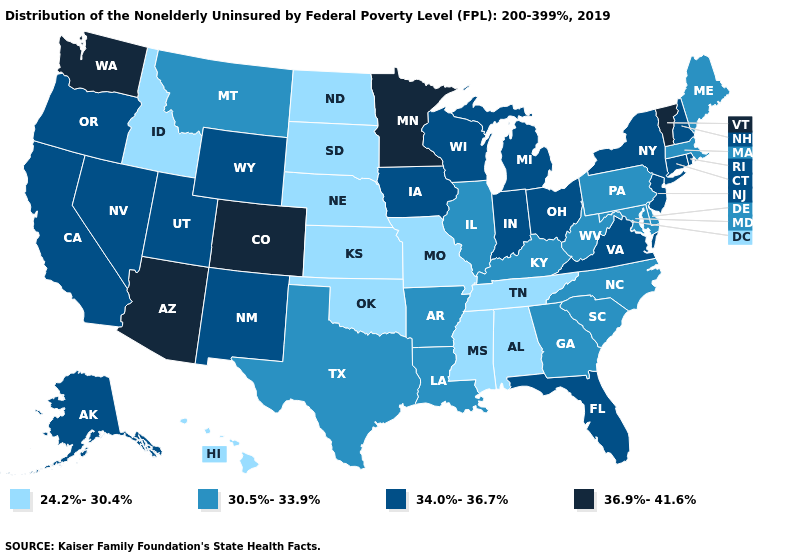Is the legend a continuous bar?
Be succinct. No. Name the states that have a value in the range 24.2%-30.4%?
Be succinct. Alabama, Hawaii, Idaho, Kansas, Mississippi, Missouri, Nebraska, North Dakota, Oklahoma, South Dakota, Tennessee. Among the states that border Connecticut , which have the highest value?
Answer briefly. New York, Rhode Island. Does the map have missing data?
Keep it brief. No. Name the states that have a value in the range 34.0%-36.7%?
Write a very short answer. Alaska, California, Connecticut, Florida, Indiana, Iowa, Michigan, Nevada, New Hampshire, New Jersey, New Mexico, New York, Ohio, Oregon, Rhode Island, Utah, Virginia, Wisconsin, Wyoming. What is the value of Tennessee?
Short answer required. 24.2%-30.4%. Does Delaware have the lowest value in the South?
Concise answer only. No. Does Missouri have the lowest value in the USA?
Give a very brief answer. Yes. Name the states that have a value in the range 34.0%-36.7%?
Write a very short answer. Alaska, California, Connecticut, Florida, Indiana, Iowa, Michigan, Nevada, New Hampshire, New Jersey, New Mexico, New York, Ohio, Oregon, Rhode Island, Utah, Virginia, Wisconsin, Wyoming. What is the highest value in the MidWest ?
Short answer required. 36.9%-41.6%. Does the first symbol in the legend represent the smallest category?
Write a very short answer. Yes. What is the highest value in the South ?
Short answer required. 34.0%-36.7%. What is the value of California?
Write a very short answer. 34.0%-36.7%. Does North Dakota have the lowest value in the USA?
Short answer required. Yes. Name the states that have a value in the range 36.9%-41.6%?
Quick response, please. Arizona, Colorado, Minnesota, Vermont, Washington. 